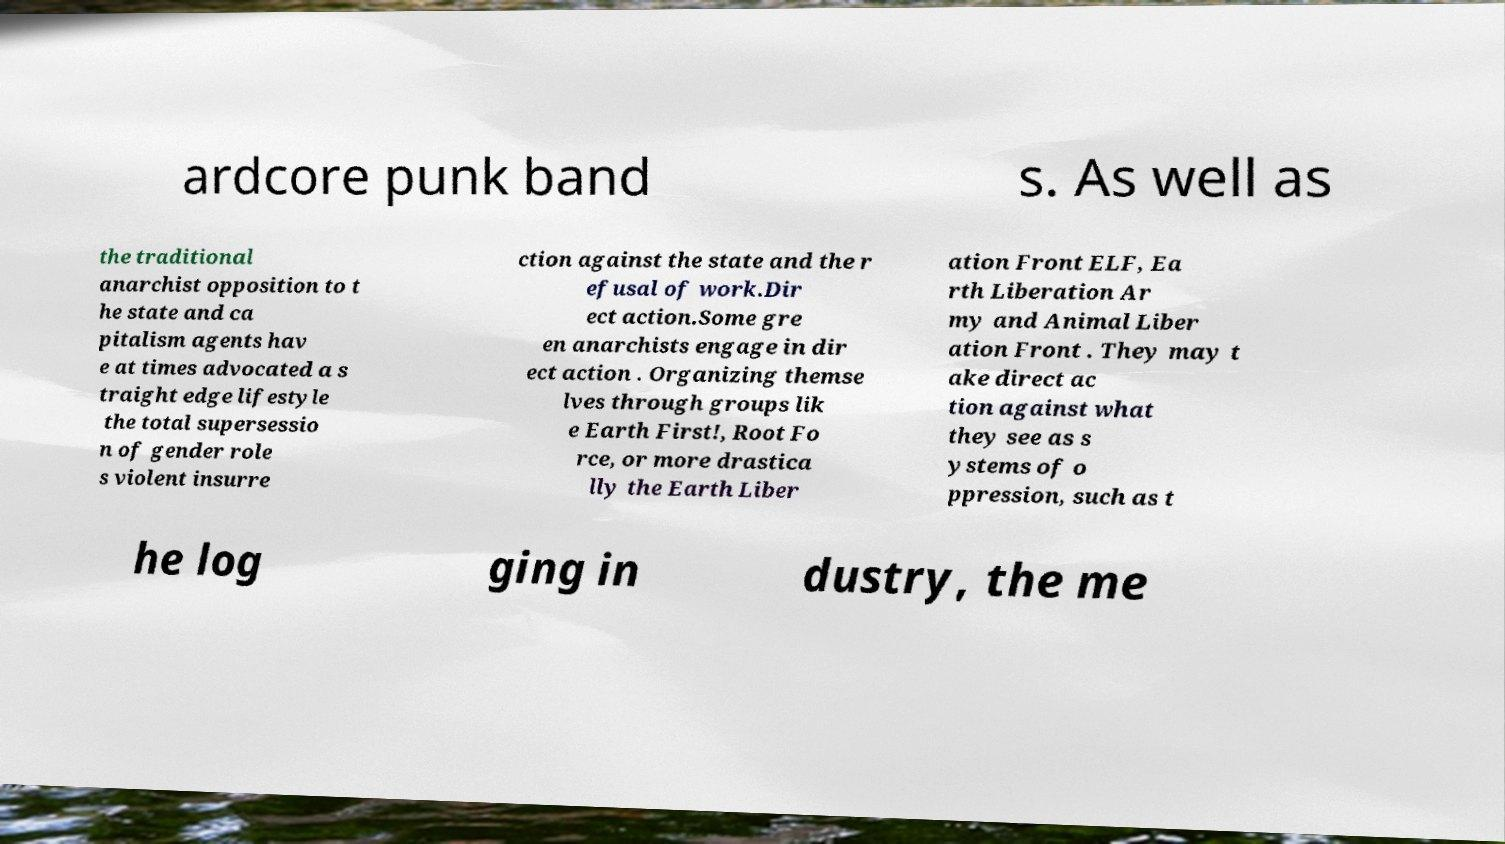Can you accurately transcribe the text from the provided image for me? ardcore punk band s. As well as the traditional anarchist opposition to t he state and ca pitalism agents hav e at times advocated a s traight edge lifestyle the total supersessio n of gender role s violent insurre ction against the state and the r efusal of work.Dir ect action.Some gre en anarchists engage in dir ect action . Organizing themse lves through groups lik e Earth First!, Root Fo rce, or more drastica lly the Earth Liber ation Front ELF, Ea rth Liberation Ar my and Animal Liber ation Front . They may t ake direct ac tion against what they see as s ystems of o ppression, such as t he log ging in dustry, the me 